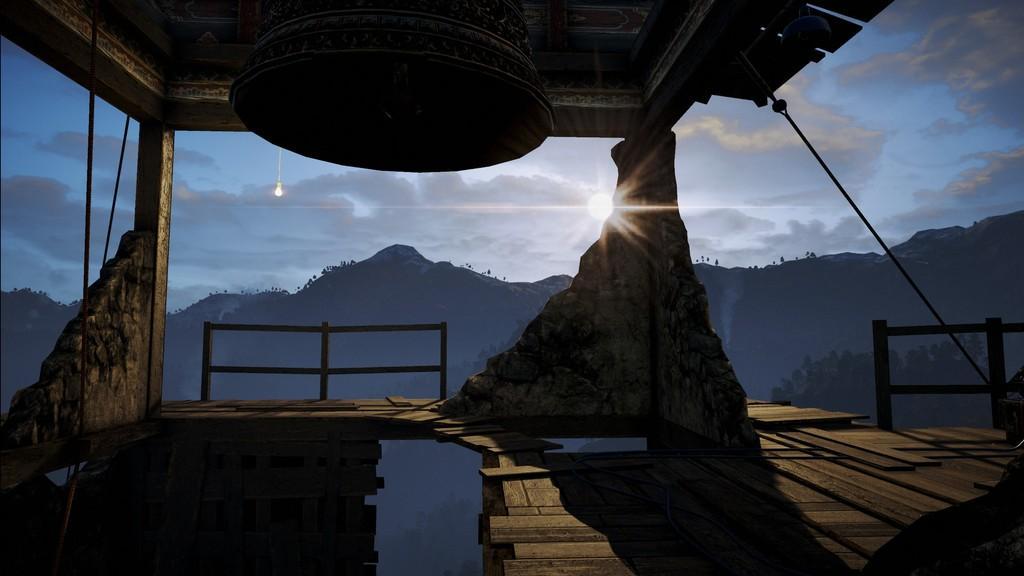Could you give a brief overview of what you see in this image? In this image in the center on the top there is a bell and in the background there is a wall and there are mountains. On the right side there is a fence and there is a rope and the sky is cloudy. 